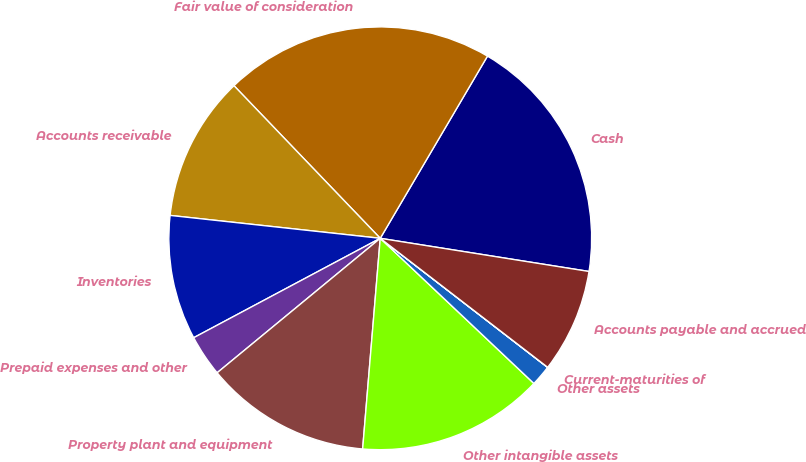<chart> <loc_0><loc_0><loc_500><loc_500><pie_chart><fcel>Cash<fcel>Fair value of consideration<fcel>Accounts receivable<fcel>Inventories<fcel>Prepaid expenses and other<fcel>Property plant and equipment<fcel>Other intangible assets<fcel>Other assets<fcel>Current-maturities of<fcel>Accounts payable and accrued<nl><fcel>19.04%<fcel>20.63%<fcel>11.11%<fcel>9.52%<fcel>3.18%<fcel>12.7%<fcel>14.28%<fcel>1.59%<fcel>0.01%<fcel>7.94%<nl></chart> 